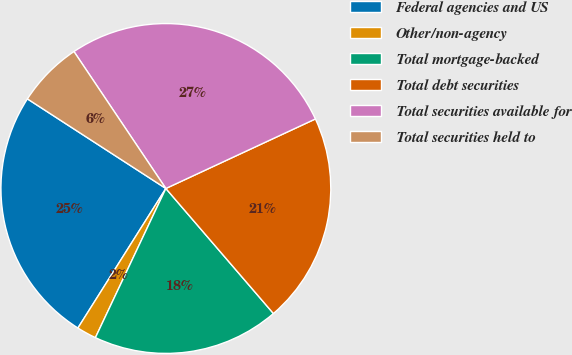Convert chart. <chart><loc_0><loc_0><loc_500><loc_500><pie_chart><fcel>Federal agencies and US<fcel>Other/non-agency<fcel>Total mortgage-backed<fcel>Total debt securities<fcel>Total securities available for<fcel>Total securities held to<nl><fcel>25.19%<fcel>1.93%<fcel>18.33%<fcel>20.62%<fcel>27.48%<fcel>6.45%<nl></chart> 